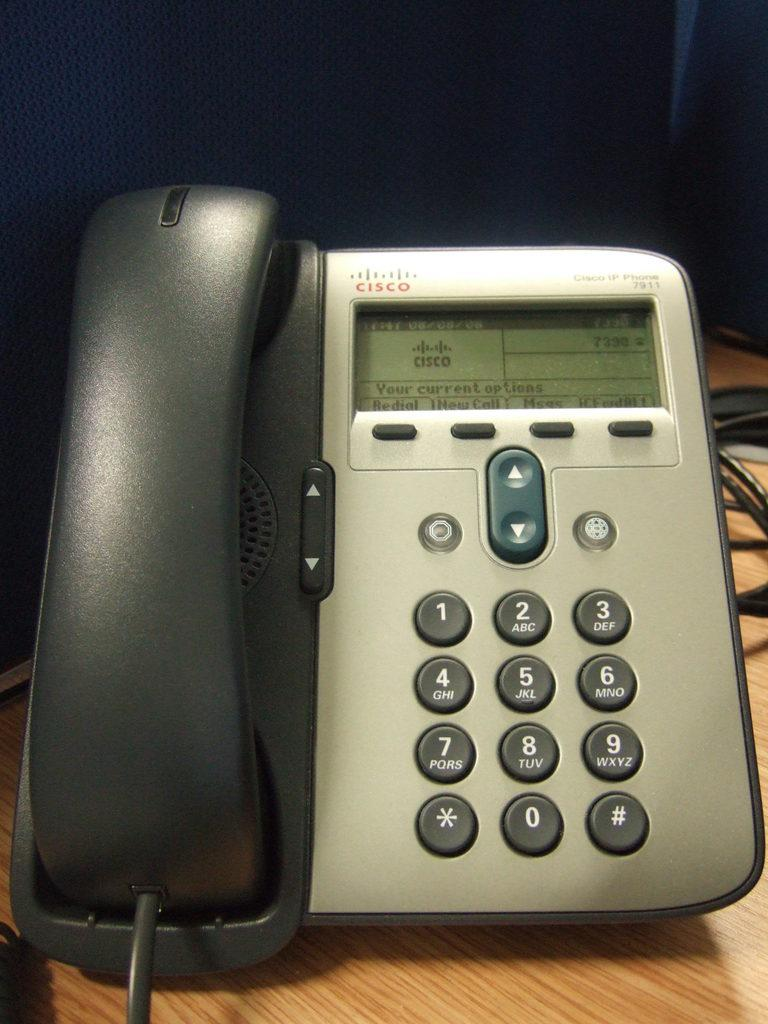What type of phone is visible in the image? There is a landline phone in the image. Where is the landline phone placed? The landline phone is placed on a wooden table. What else can be seen in the image besides the phone? Cables are visible in the image. What is the color of the background in the image? The background of the image is black in color. What is the opinion of the birthday party attendees about the street in the image? There is no mention of a birthday party or attendees in the image, nor is there any street visible. 